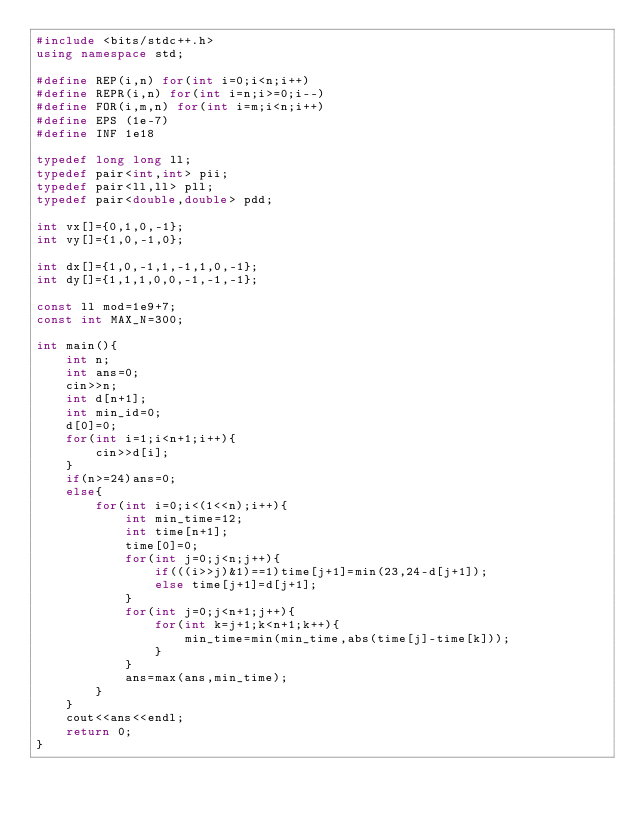<code> <loc_0><loc_0><loc_500><loc_500><_C++_>#include <bits/stdc++.h>
using namespace std;

#define REP(i,n) for(int i=0;i<n;i++)
#define REPR(i,n) for(int i=n;i>=0;i--)
#define FOR(i,m,n) for(int i=m;i<n;i++)
#define EPS (1e-7)
#define INF 1e18

typedef long long ll;
typedef pair<int,int> pii;
typedef pair<ll,ll> pll;
typedef pair<double,double> pdd;

int vx[]={0,1,0,-1};
int vy[]={1,0,-1,0};

int dx[]={1,0,-1,1,-1,1,0,-1};
int dy[]={1,1,1,0,0,-1,-1,-1};

const ll mod=1e9+7;
const int MAX_N=300;

int main(){
	int n;
	int ans=0;
	cin>>n;
	int d[n+1];
	int min_id=0;
	d[0]=0;
	for(int i=1;i<n+1;i++){
		cin>>d[i];
	}
	if(n>=24)ans=0;
	else{
		for(int i=0;i<(1<<n);i++){
			int min_time=12;
			int time[n+1];
			time[0]=0;
			for(int j=0;j<n;j++){
				if(((i>>j)&1)==1)time[j+1]=min(23,24-d[j+1]);
				else time[j+1]=d[j+1];
			}
			for(int j=0;j<n+1;j++){
				for(int k=j+1;k<n+1;k++){
					min_time=min(min_time,abs(time[j]-time[k]));
				}
			}
			ans=max(ans,min_time);
		}
	}
	cout<<ans<<endl;
	return 0;
}</code> 